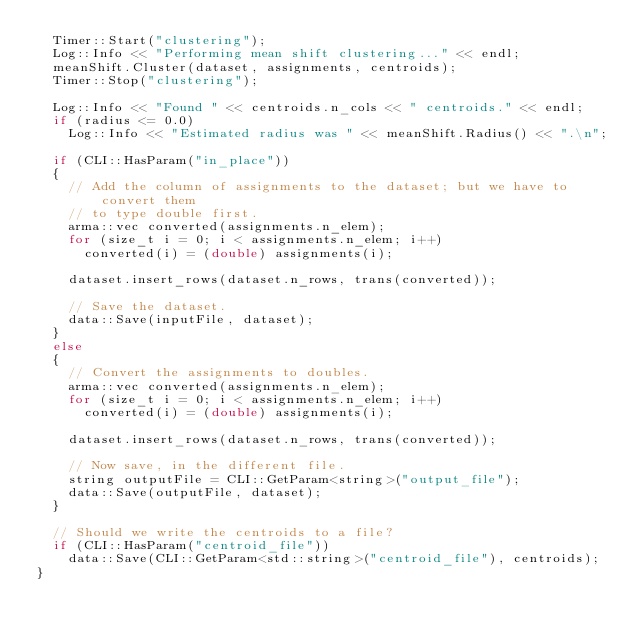Convert code to text. <code><loc_0><loc_0><loc_500><loc_500><_C++_>  Timer::Start("clustering");
  Log::Info << "Performing mean shift clustering..." << endl;
  meanShift.Cluster(dataset, assignments, centroids);
  Timer::Stop("clustering");

  Log::Info << "Found " << centroids.n_cols << " centroids." << endl;
  if (radius <= 0.0)
    Log::Info << "Estimated radius was " << meanShift.Radius() << ".\n";

  if (CLI::HasParam("in_place"))
  {
    // Add the column of assignments to the dataset; but we have to convert them
    // to type double first.
    arma::vec converted(assignments.n_elem);
    for (size_t i = 0; i < assignments.n_elem; i++)
      converted(i) = (double) assignments(i);

    dataset.insert_rows(dataset.n_rows, trans(converted));

    // Save the dataset.
    data::Save(inputFile, dataset);
  }
  else
  {
    // Convert the assignments to doubles.
    arma::vec converted(assignments.n_elem);
    for (size_t i = 0; i < assignments.n_elem; i++)
      converted(i) = (double) assignments(i);

    dataset.insert_rows(dataset.n_rows, trans(converted));

    // Now save, in the different file.
    string outputFile = CLI::GetParam<string>("output_file");
    data::Save(outputFile, dataset);
  }

  // Should we write the centroids to a file?
  if (CLI::HasParam("centroid_file"))
    data::Save(CLI::GetParam<std::string>("centroid_file"), centroids);
}
</code> 